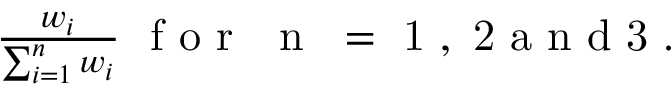<formula> <loc_0><loc_0><loc_500><loc_500>\begin{array} { r } { \frac { w _ { i } } { \sum _ { i = 1 } ^ { n } w _ { i } } f o r { n } = 1 , 2 a n d 3 . } \end{array}</formula> 